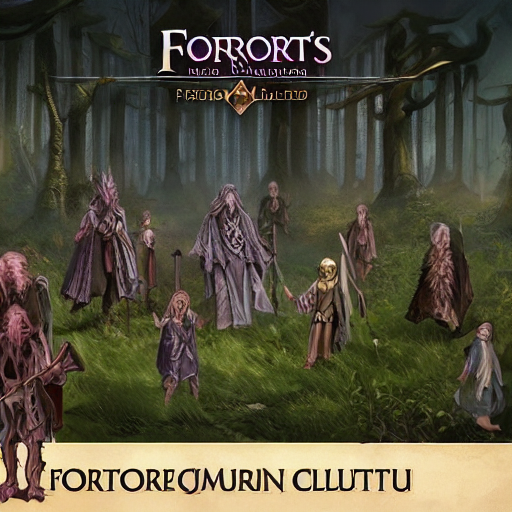What might be the story behind these characters? Looking at the characters in this artwork, they appear to be part of a fantastical race or cult, possibly druids or sorcerers, gathering in a secluded forest for a significant occasion. The diversity in their attire and the enigmatic symbols on their garments could indicate varying ranks or roles within their society. This meeting could be a conclave where they discuss arcane matters, perform a ritual, or prepare for an impending event that requires their collective expertise and power. 